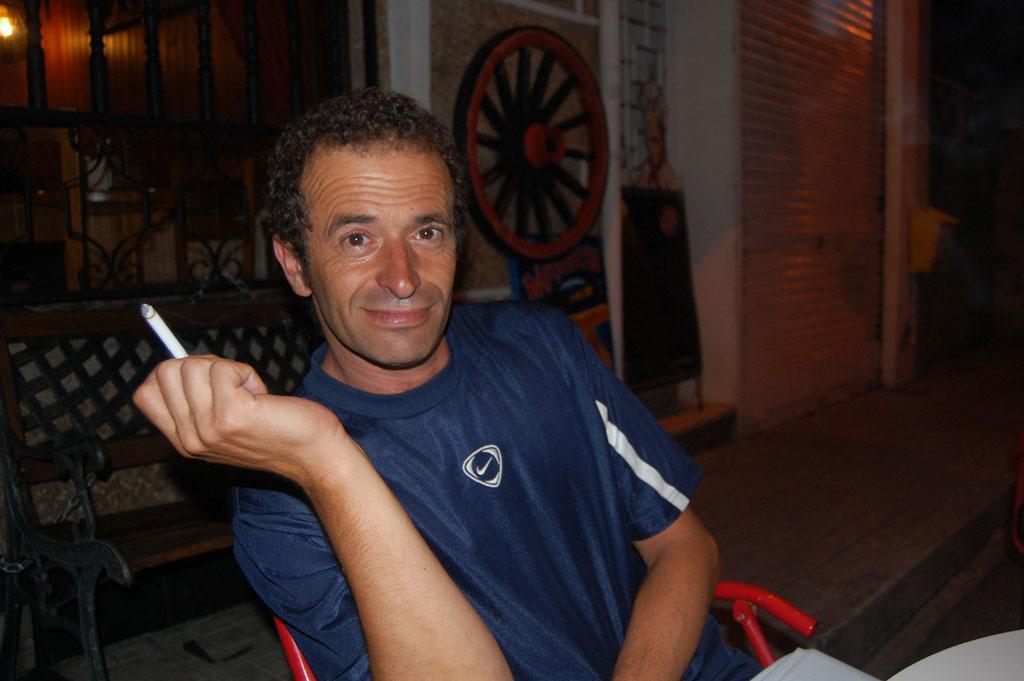Describe this image in one or two sentences. In this picture there is a person wearing blue shirt is sitting in a chair and holding a cigarette in his hand and there are some other objects behind it. 